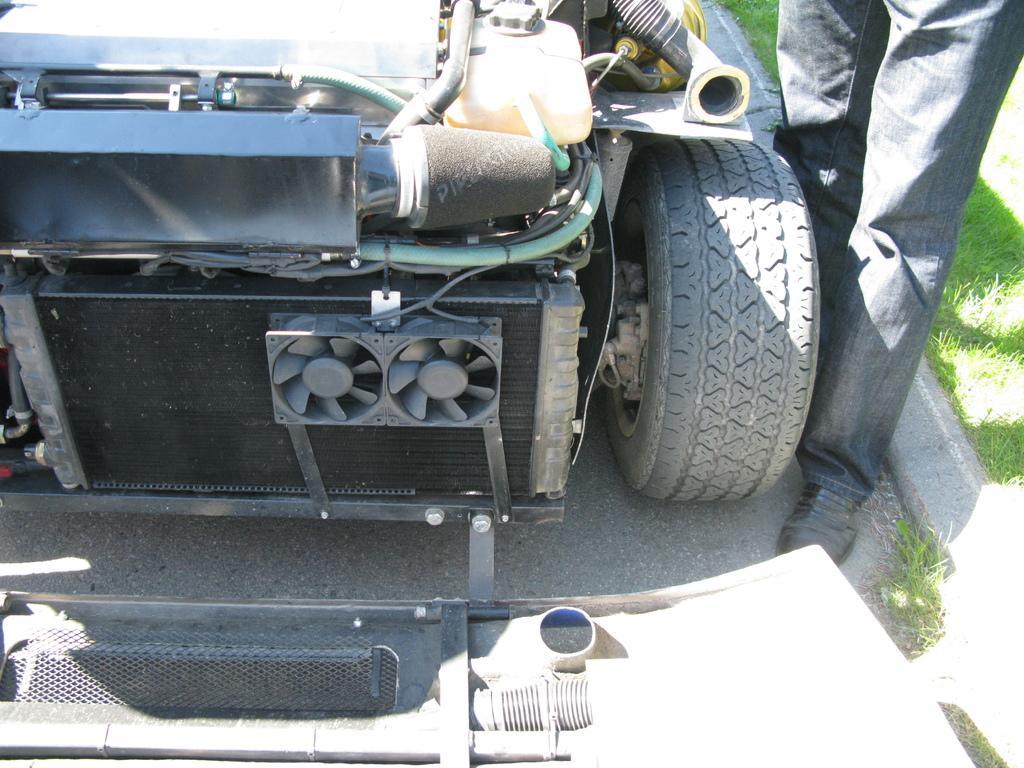Please provide a concise description of this image. In this picture we can see a vehicle on the left side, there are two fans in the middle, on the right side we can see a person and grass. 